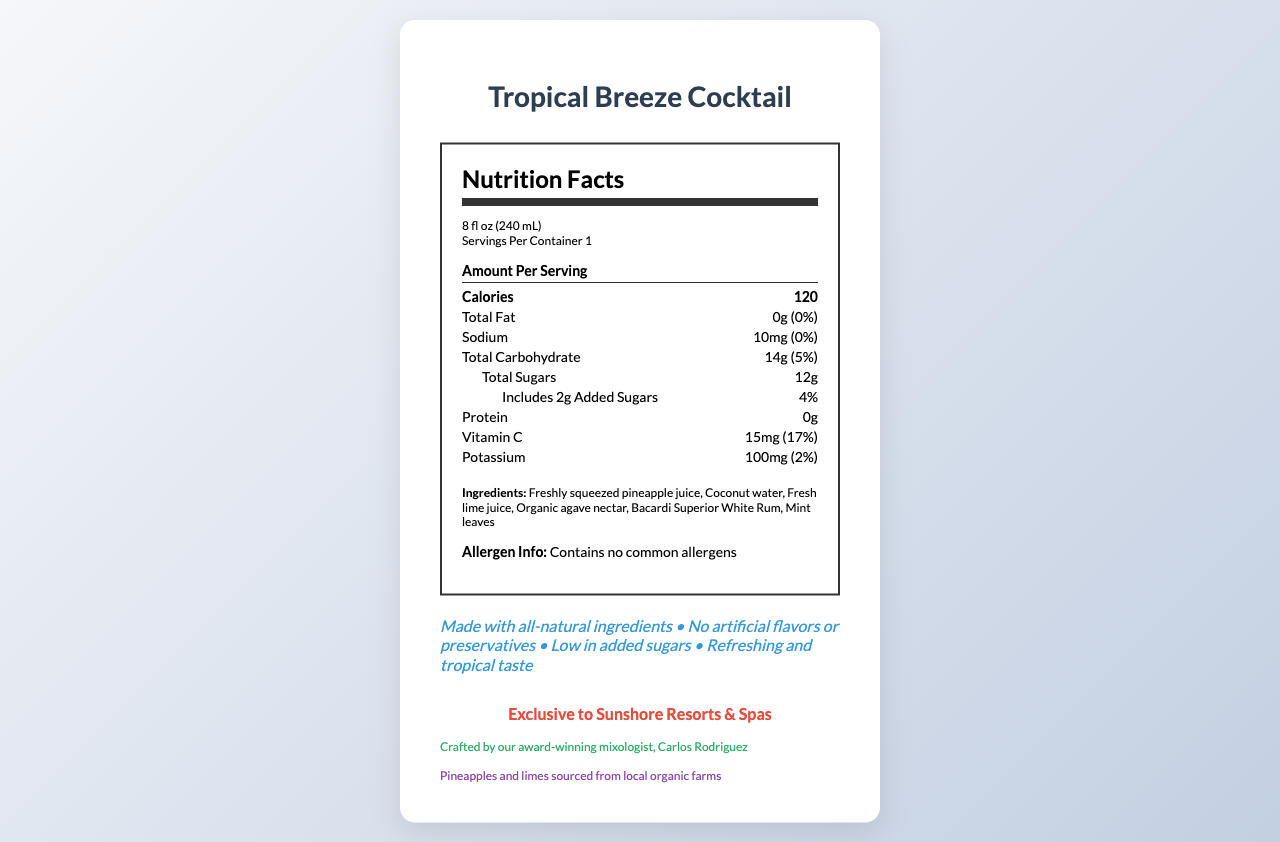What is the serving size of the Tropical Breeze Cocktail? The serving size is listed at the top of the nutrition label as "8 fl oz (240 mL)".
Answer: 8 fl oz (240 mL) How many calories are there per serving? The document states under the "Amount Per Serving" section that there are 120 calories.
Answer: 120 What percentage of the daily value of Vitamin C does one serving provide? Under the nutrient section, it shows that Vitamin C provides 17% of the daily value per serving.
Answer: 17% Who crafted the Tropical Breeze Cocktail? The bartender note at the bottom of the document indicates that it was crafted by Carlos Rodriguez, their award-winning mixologist.
Answer: Carlos Rodriguez What are the main ingredients of the Tropical Breeze Cocktail? The ingredients list in the document provides these main components of the cocktail.
Answer: Freshly squeezed pineapple juice, Coconut water, Fresh lime juice, Organic agave nectar, Bacardi Superior White Rum, Mint leaves What is the sodium content in one serving? The sodium content per serving is listed as 10mg.
Answer: 10mg Does the Tropical Breeze Cocktail contain any common allergens? The allergen information section indicates that it contains no common allergens.
Answer: No Which of the following best describes the cocktail's distinguishing features?
A. High in protein and fiber
B. Made with all-natural ingredients and low in added sugars
C. Contains artificial flavors and preservatives The promotional claims section states that it is made with all-natural ingredients and low in added sugars.
Answer: B The cocktail includes added sugars. How much and what percentage of the daily value does it represent? It includes 2g of added sugars, which is 4% of the daily value as stated in the document under the total sugars section.
Answer: 2g, 4% Is the Tropical Breeze Cocktail high in potassium? It contains 100mg of potassium, which is only 2% of the daily value, not enough to be considered high.
Answer: No Provide a summary of the document. The document succinctly outlines the essential nutritional and promotional information for the Tropical Breeze Cocktail served at Sunshore Resorts & Spas.
Answer: The Nutrition Facts Label for the Tropical Breeze Cocktail details its serving size, calorie content, and nutritional values, including information on fat, sodium, carbohydrates, sugars, protein, Vitamin C, and potassium. The cocktail is made entirely from natural ingredients, has no artificial flavors or preservatives, and is low in added sugars. Useful additional information includes its lack of common allergens, its exclusive availability at Sunshore Resorts & Spas, creation by award-winning mixologist Carlos Rodriguez, and the sustainable sourcing of its key ingredients. What is the total carbohydrate content in one serving? According to the nutrition label, the total carbohydrate content per serving is 14g.
Answer: 14g What claims does the document make about preservatives in the cocktail? The promotional claims section explicitly states that the cocktail contains no artificial flavors or preservatives.
Answer: No artificial flavors or preservatives Where does the hotel source its pineapples and limes from for this cocktail? The sustainable sourcing section mentions that the pineapples and limes are sourced from local organic farms.
Answer: Local organic farms Which nutrients are indicated to have 0% daily value in the cocktail? A. Total Fat B. Sodium C. Protein D. Potassium The document states that Total Fat has 0% daily value and Sodium has 0%. Protein and Potassium have indicated values greater than 0%.
Answer: A What is the percentage of daily value for total carbohydrates provided by one serving? It is mentioned under the total carbohydrate section that the percentage of daily value is 5%.
Answer: 5% What are the visual features that emphasize the cocktail's natural and healthy ingredients? These claims stand out in the document, highlighting the cocktail's commitment to natural and healthy ingredients.
Answer: The promotional claims such as "Made with all-natural ingredients," "No artificial flavors or preservatives," and "Low in added sugars" How was the screenshot of this document captured? The document does not provide details about how the screenshot was captured, including any technical aspects or tools used.
Answer: Not enough information Describe the taste experience of the Tropical Breeze Cocktail based on the promotional claims. The promotional claims mention that the cocktail has a "Refreshing and tropical taste".
Answer: Refreshing and tropical 